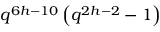Convert formula to latex. <formula><loc_0><loc_0><loc_500><loc_500>q ^ { 6 h - 1 0 } \left ( q ^ { 2 h - 2 } - 1 \right )</formula> 